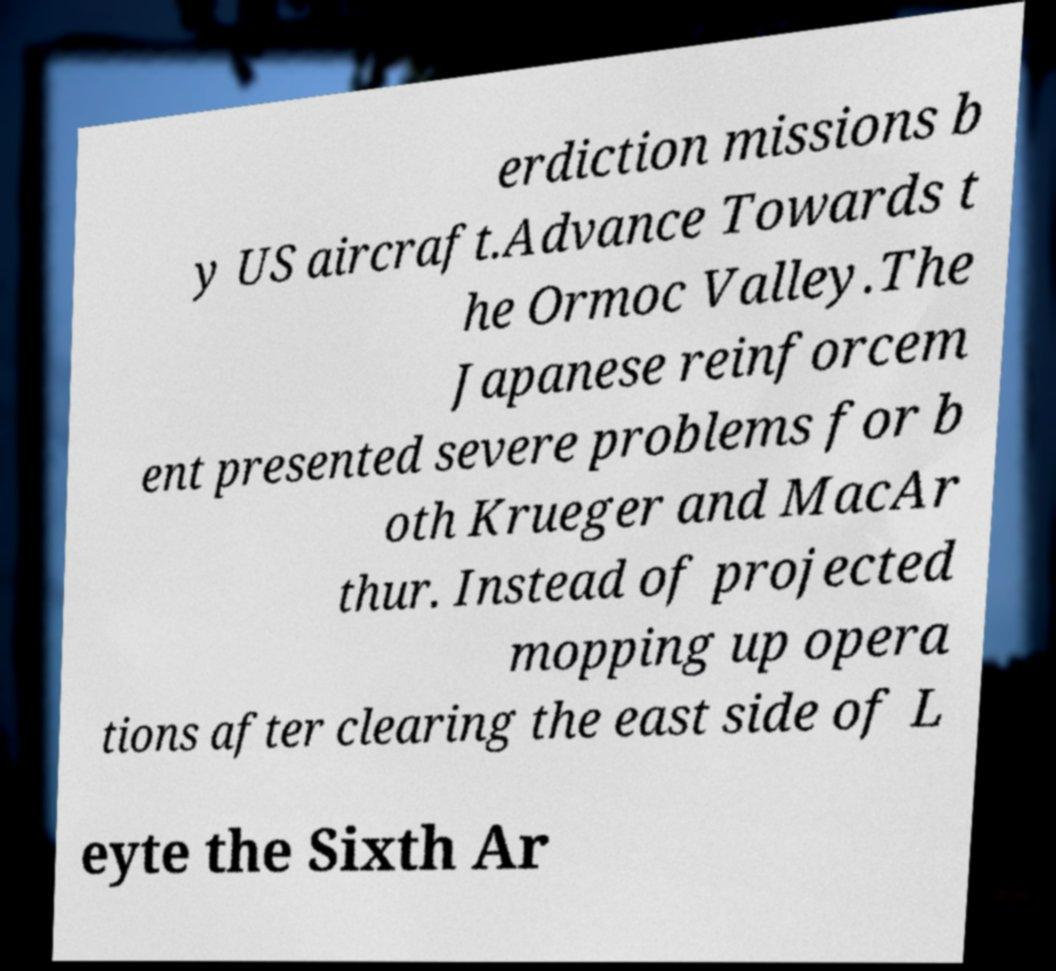Could you extract and type out the text from this image? erdiction missions b y US aircraft.Advance Towards t he Ormoc Valley.The Japanese reinforcem ent presented severe problems for b oth Krueger and MacAr thur. Instead of projected mopping up opera tions after clearing the east side of L eyte the Sixth Ar 